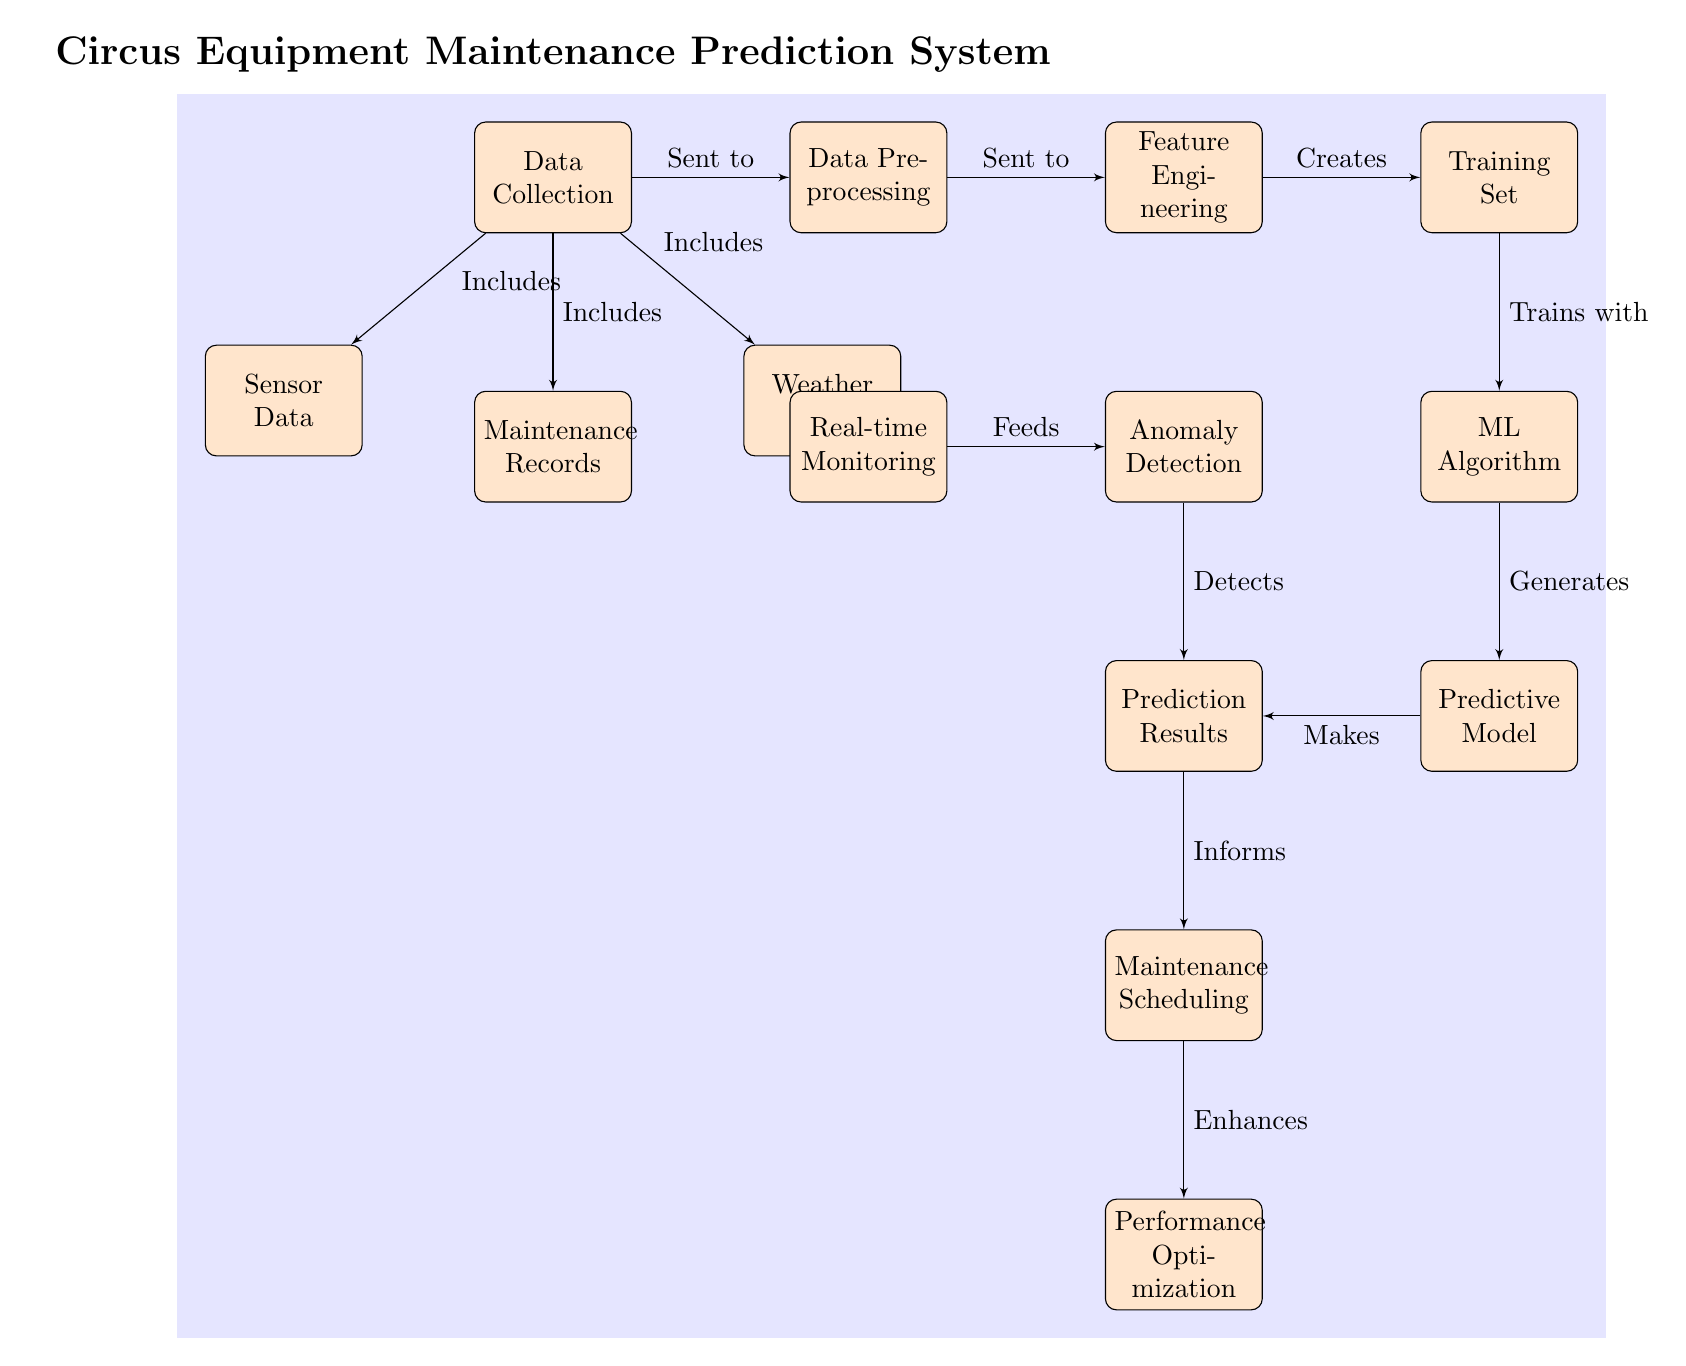What are the three types of data included in the Data Collection? The diagram indicates that the Data Collection node includes Sensor Data, Maintenance Records, and Weather Data. By looking at the edges from the Data Collection node, we can see these three connections labeled as "Includes."
Answer: Sensor Data, Maintenance Records, Weather Data How many blocks are shown in the diagram? Counting the total number of blocks, we find there are 14 blocks placed in the diagram. Each block corresponds to a task or a step in the equipment maintenance prediction process.
Answer: 14 Which block directly feeds into the Anomaly Detection node? The diagram shows that the Real-time Monitoring block directly feeds into the Anomaly Detection node. The arrow labeled "Feeds" illustrates this relationship.
Answer: Real-time Monitoring What creates the Training Set? The diagram indicates that Feature Engineering is the process that creates the Training Set. This relationship is shown with the arrow labeled "Creates".
Answer: Feature Engineering What does the Predictive Model generate? According to the diagram, the Predictive Model generates the Prediction Results. This connection is indicated with the arrow labeled "Generates".
Answer: Prediction Results Which step informs the Maintenance Scheduling? The Prediction Results step informs the Maintenance Scheduling block as indicated by the arrow labeled "Informs" in the diagram. This shows the flow of information from the results to the scheduling process.
Answer: Prediction Results How many nodes are involved before establishing the Predictive Model? There are five nodes involved before establishing the Predictive Model: Data Collection, Data Preprocessing, Feature Engineering, Training Set, and ML Algorithm. By counting these sequence nodes, we can identify them clearly leading up to the Predictive Model.
Answer: 5 What enhances Performance Optimization? The diagram shows that the Maintenance Scheduling enhances Performance Optimization, evidenced by the arrow labeled "Enhances" leading to the last block.
Answer: Maintenance Scheduling 